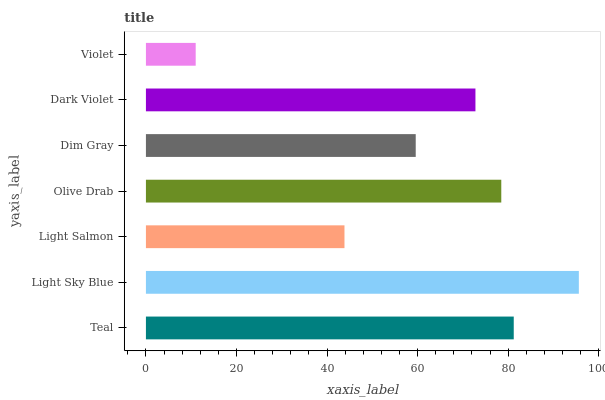Is Violet the minimum?
Answer yes or no. Yes. Is Light Sky Blue the maximum?
Answer yes or no. Yes. Is Light Salmon the minimum?
Answer yes or no. No. Is Light Salmon the maximum?
Answer yes or no. No. Is Light Sky Blue greater than Light Salmon?
Answer yes or no. Yes. Is Light Salmon less than Light Sky Blue?
Answer yes or no. Yes. Is Light Salmon greater than Light Sky Blue?
Answer yes or no. No. Is Light Sky Blue less than Light Salmon?
Answer yes or no. No. Is Dark Violet the high median?
Answer yes or no. Yes. Is Dark Violet the low median?
Answer yes or no. Yes. Is Violet the high median?
Answer yes or no. No. Is Light Salmon the low median?
Answer yes or no. No. 